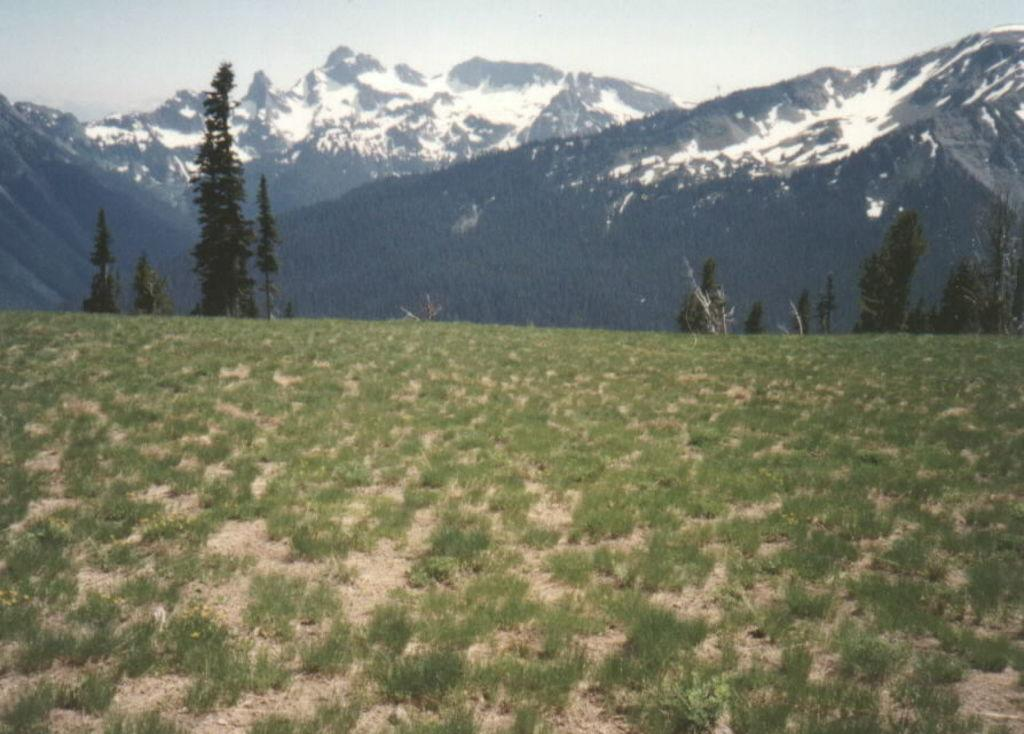What type of vegetation can be seen in the image? There are shrubs and trees in the image. What natural landforms are visible in the image? There are mountains in the image. What part of the natural environment is visible in the image? The sky is visible in the image. Can you tell me how many goats are climbing the sponge in the image? There are no goats or sponges present in the image. What type of substance is covering the trees in the image? There is no substance covering the trees in the image; the trees appear to be their natural state. 